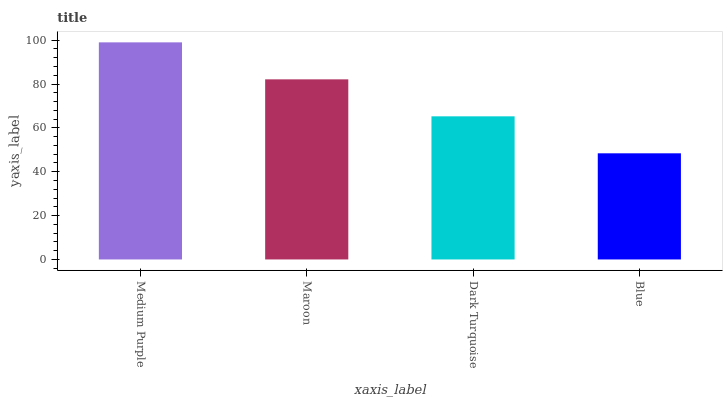Is Blue the minimum?
Answer yes or no. Yes. Is Medium Purple the maximum?
Answer yes or no. Yes. Is Maroon the minimum?
Answer yes or no. No. Is Maroon the maximum?
Answer yes or no. No. Is Medium Purple greater than Maroon?
Answer yes or no. Yes. Is Maroon less than Medium Purple?
Answer yes or no. Yes. Is Maroon greater than Medium Purple?
Answer yes or no. No. Is Medium Purple less than Maroon?
Answer yes or no. No. Is Maroon the high median?
Answer yes or no. Yes. Is Dark Turquoise the low median?
Answer yes or no. Yes. Is Dark Turquoise the high median?
Answer yes or no. No. Is Medium Purple the low median?
Answer yes or no. No. 